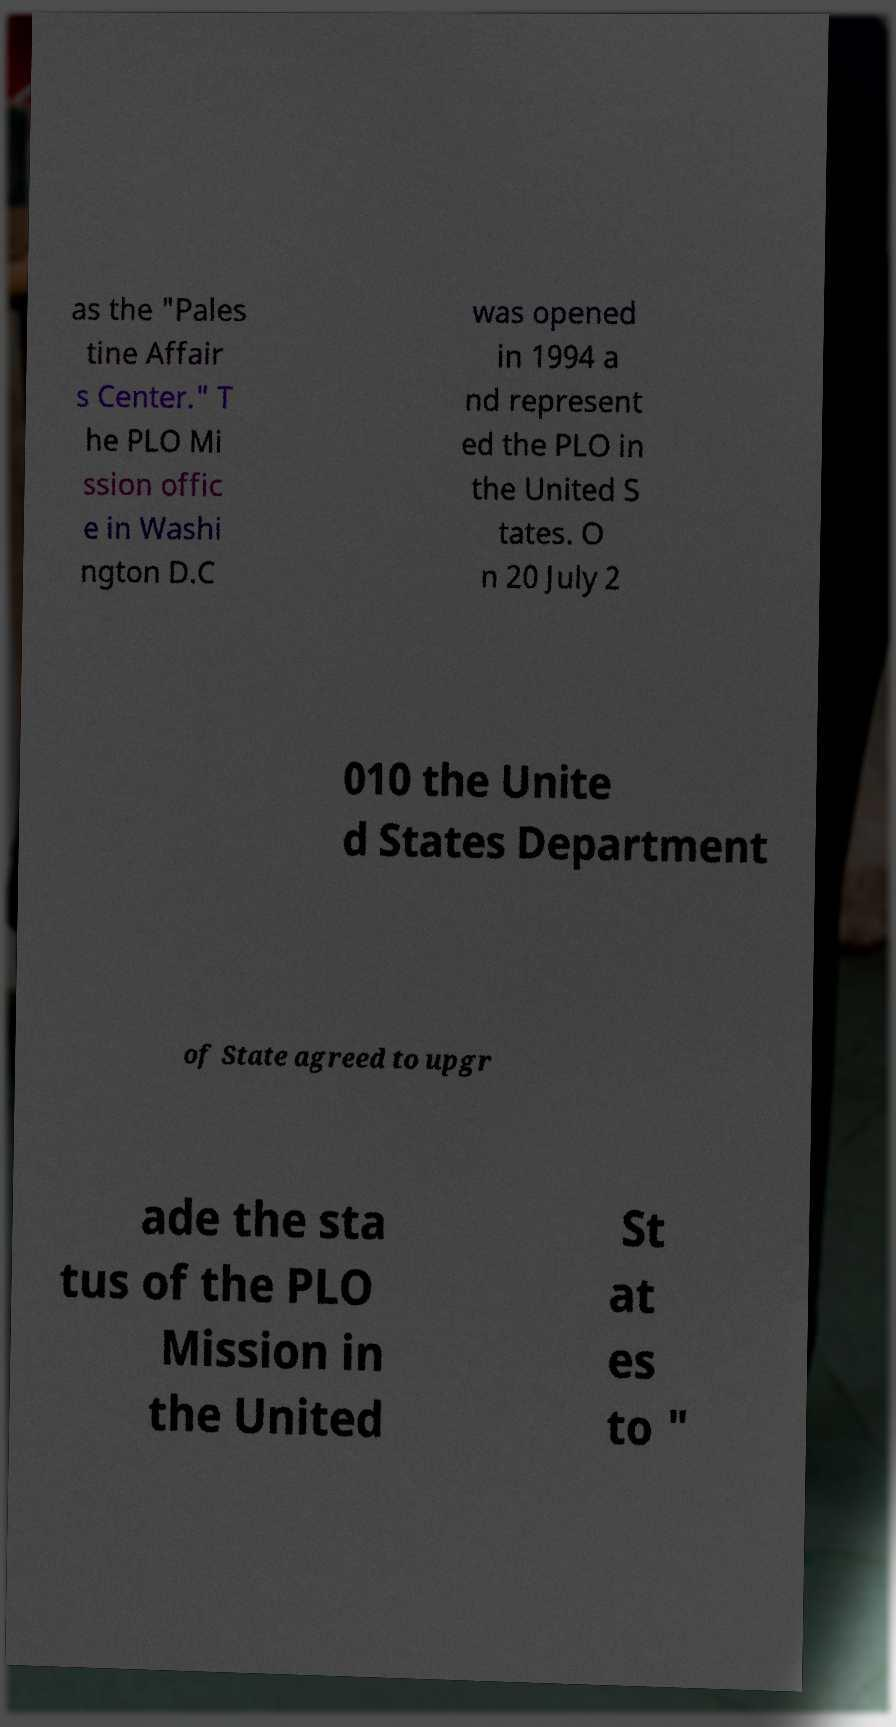Please read and relay the text visible in this image. What does it say? as the "Pales tine Affair s Center." T he PLO Mi ssion offic e in Washi ngton D.C was opened in 1994 a nd represent ed the PLO in the United S tates. O n 20 July 2 010 the Unite d States Department of State agreed to upgr ade the sta tus of the PLO Mission in the United St at es to " 